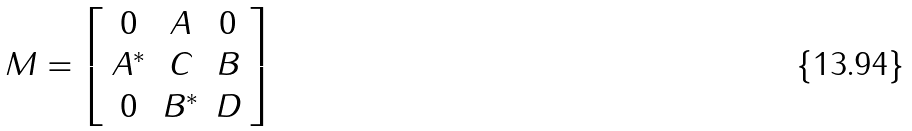<formula> <loc_0><loc_0><loc_500><loc_500>M = \left [ \begin{array} { c c c } 0 & A & 0 \\ A ^ { * } & C & B \\ 0 & B ^ { * } & D \end{array} \right ]</formula> 